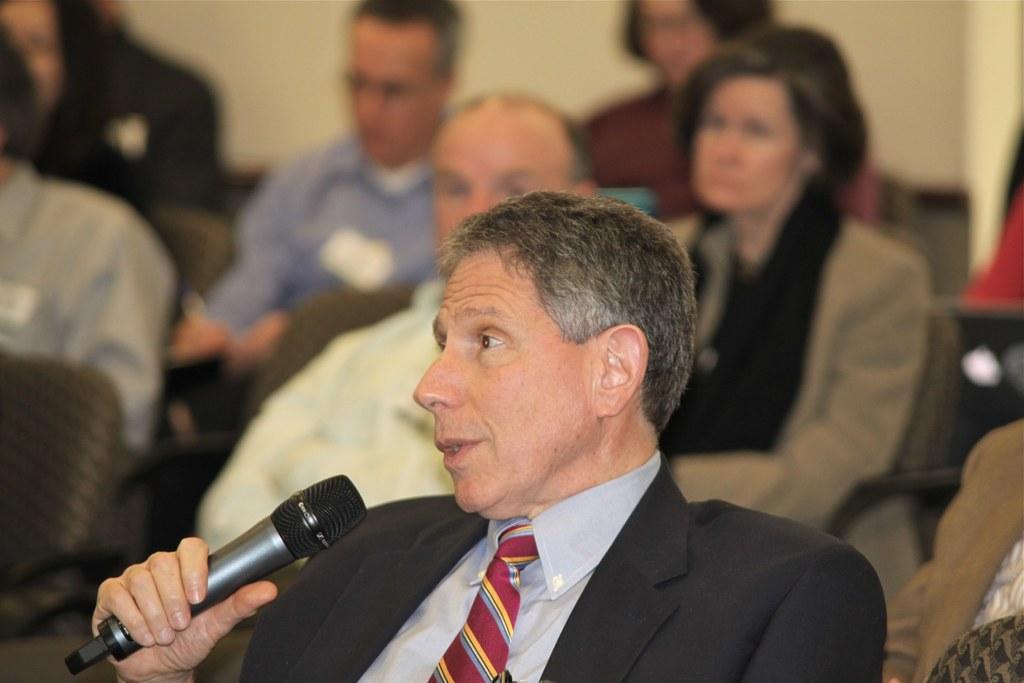How would you summarize this image in a sentence or two? This picture shows a group of people seated on the chairs and we see a man speaking with the help of a microphone in his hand 